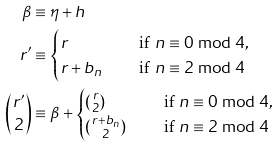Convert formula to latex. <formula><loc_0><loc_0><loc_500><loc_500>\beta & \equiv \eta + h \\ r ^ { \prime } & \equiv \begin{cases} r & \quad \text { if } n \equiv 0 \bmod 4 , \\ r + b _ { n } & \quad \text { if } n \equiv 2 \bmod 4 \end{cases} \\ \binom { r ^ { \prime } } 2 & \equiv \beta + \begin{cases} \binom { r } { 2 } & \quad \text { if } n \equiv 0 \bmod 4 , \\ \binom { r + b _ { n } } 2 & \quad \text { if } n \equiv 2 \bmod 4 \end{cases}</formula> 